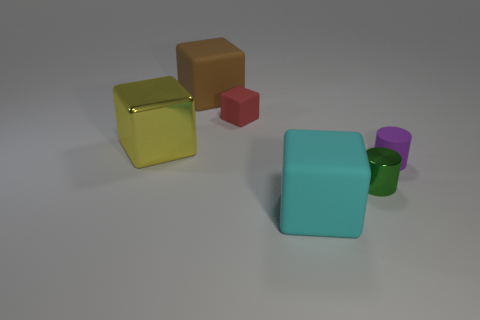How many spheres are large brown objects or tiny purple objects?
Provide a succinct answer. 0. How many red objects are the same shape as the yellow shiny object?
Offer a terse response. 1. Are there more yellow shiny blocks that are in front of the green thing than purple cylinders that are in front of the purple matte cylinder?
Your response must be concise. No. Do the large thing in front of the metallic cylinder and the small shiny cylinder have the same color?
Your response must be concise. No. The green metallic cylinder is what size?
Provide a succinct answer. Small. There is a yellow thing that is the same size as the brown rubber thing; what material is it?
Ensure brevity in your answer.  Metal. There is a rubber object that is to the right of the big cyan matte cube; what color is it?
Your answer should be compact. Purple. How many big brown things are there?
Offer a very short reply. 1. Are there any red objects that are left of the big thing that is in front of the metal object on the right side of the small red matte object?
Your answer should be very brief. Yes. What shape is the other rubber object that is the same size as the brown rubber thing?
Offer a terse response. Cube. 